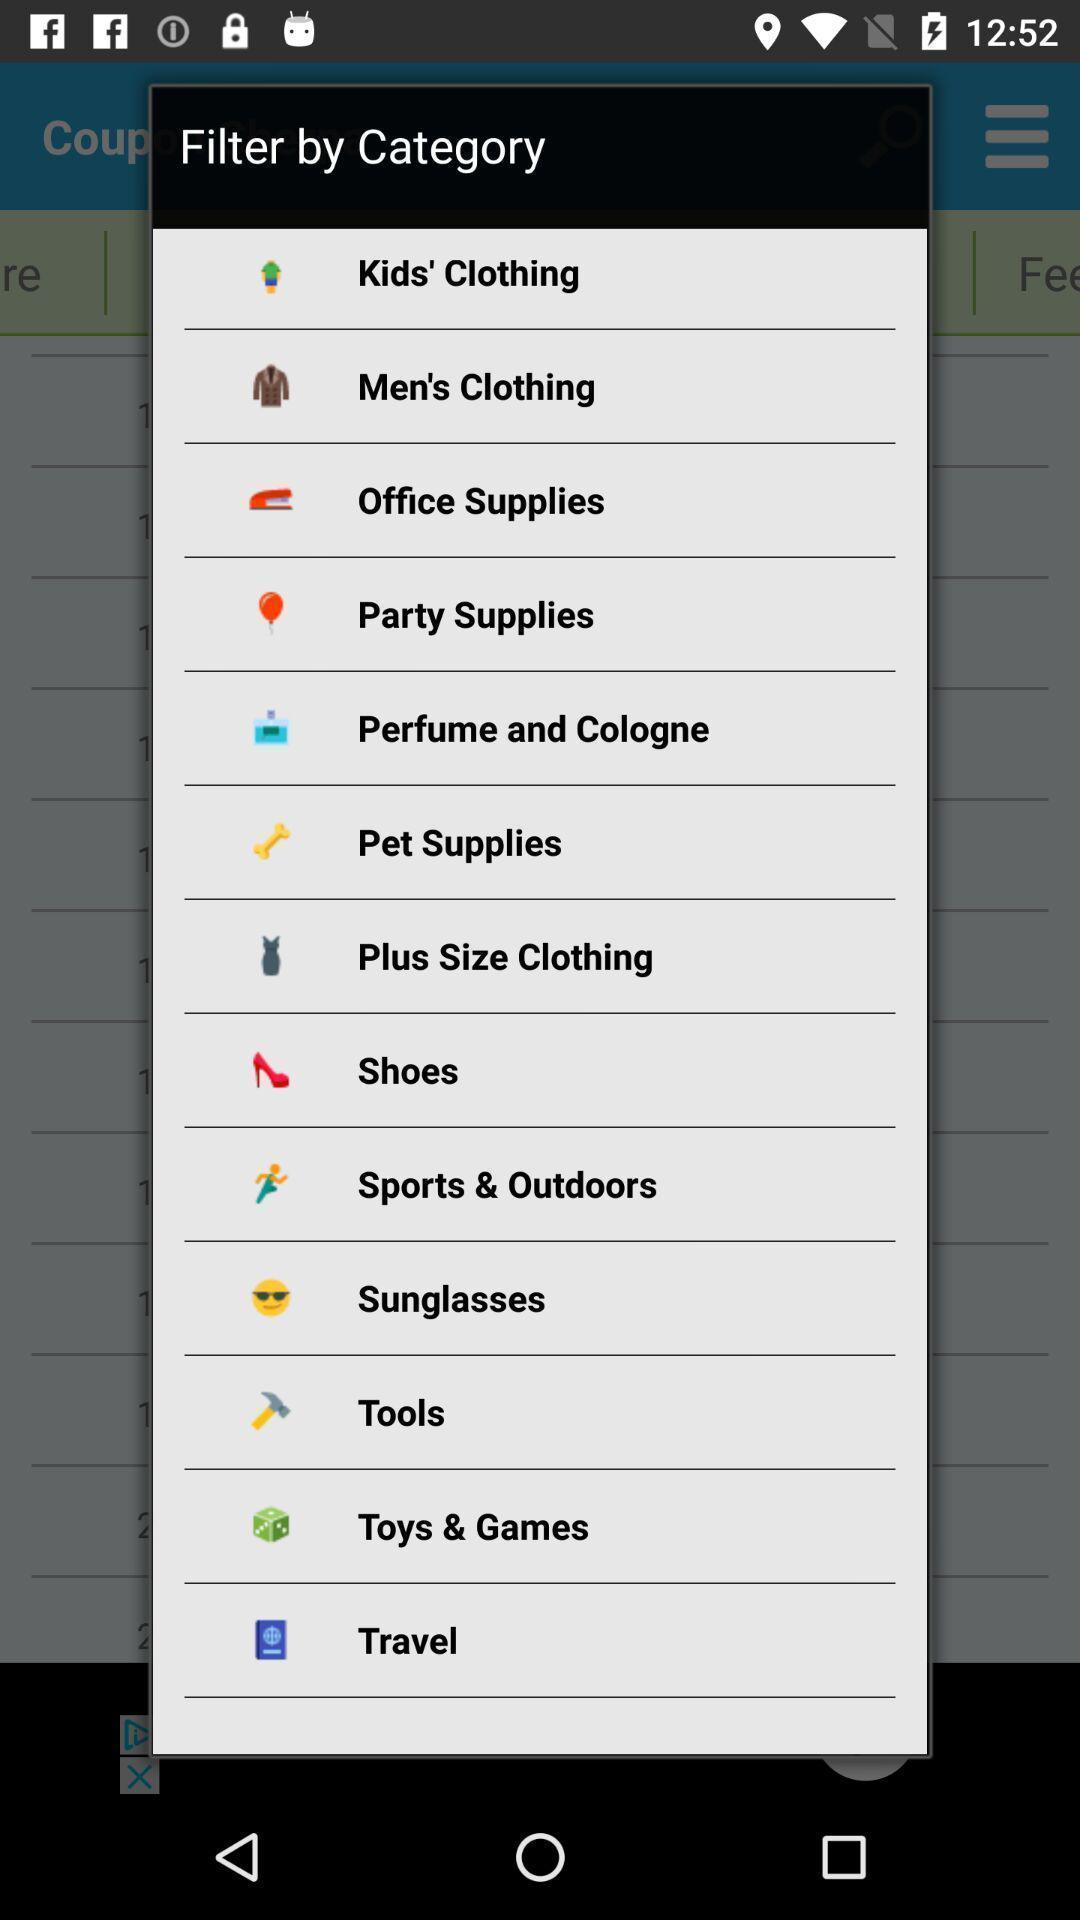What can you discern from this picture? Pop-up page asking to select category in shopping app. 